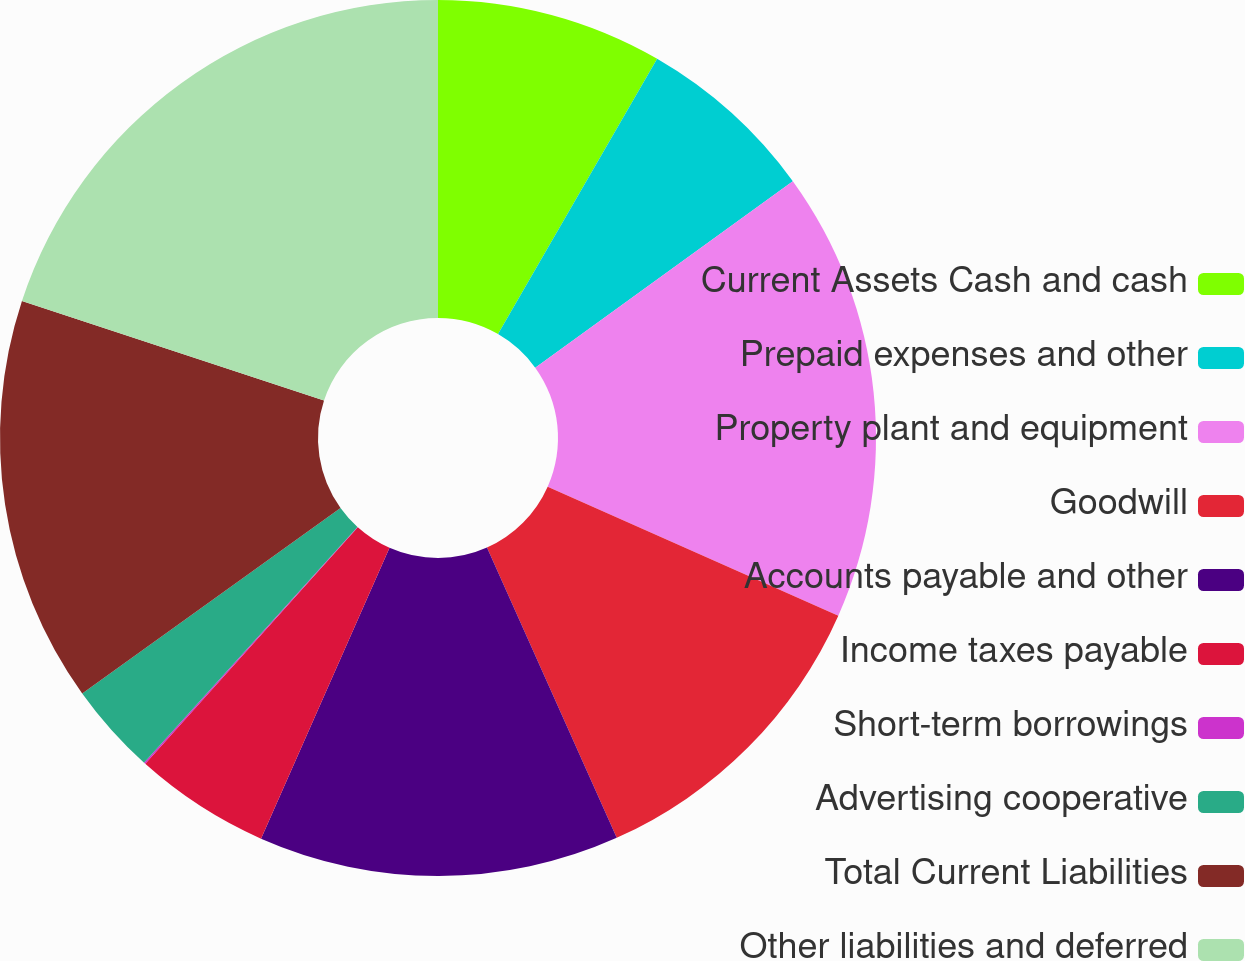Convert chart. <chart><loc_0><loc_0><loc_500><loc_500><pie_chart><fcel>Current Assets Cash and cash<fcel>Prepaid expenses and other<fcel>Property plant and equipment<fcel>Goodwill<fcel>Accounts payable and other<fcel>Income taxes payable<fcel>Short-term borrowings<fcel>Advertising cooperative<fcel>Total Current Liabilities<fcel>Other liabilities and deferred<nl><fcel>8.34%<fcel>6.69%<fcel>16.62%<fcel>11.66%<fcel>13.31%<fcel>5.03%<fcel>0.06%<fcel>3.38%<fcel>14.97%<fcel>19.94%<nl></chart> 